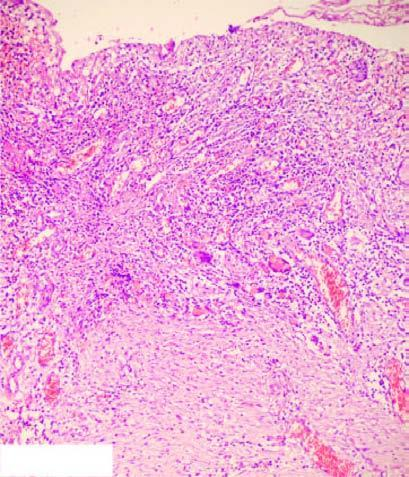does the photomicrograph on right show necrotic debris, ulceration and inflammation on the mucosal surface?
Answer the question using a single word or phrase. Yes 